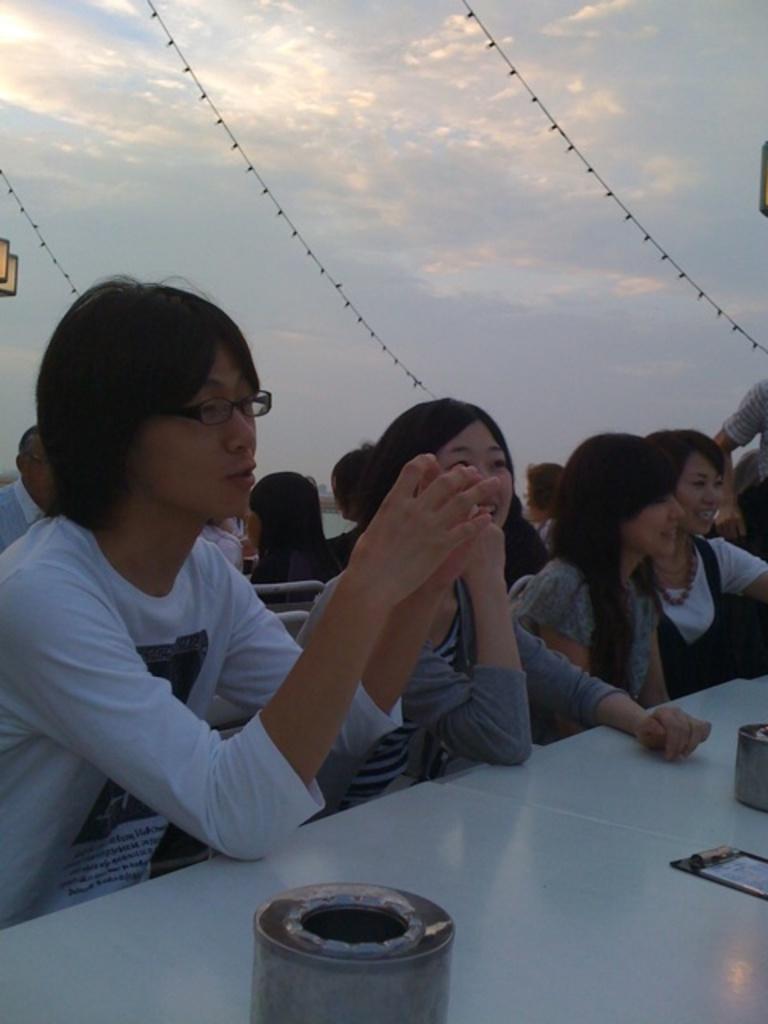Describe this image in one or two sentences. In this picture I can see group of people sitting, there are some objects on the table, and in the background there is the sky. 